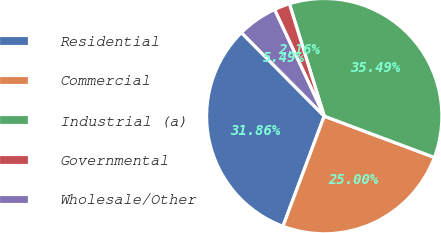<chart> <loc_0><loc_0><loc_500><loc_500><pie_chart><fcel>Residential<fcel>Commercial<fcel>Industrial (a)<fcel>Governmental<fcel>Wholesale/Other<nl><fcel>31.86%<fcel>25.0%<fcel>35.49%<fcel>2.16%<fcel>5.49%<nl></chart> 